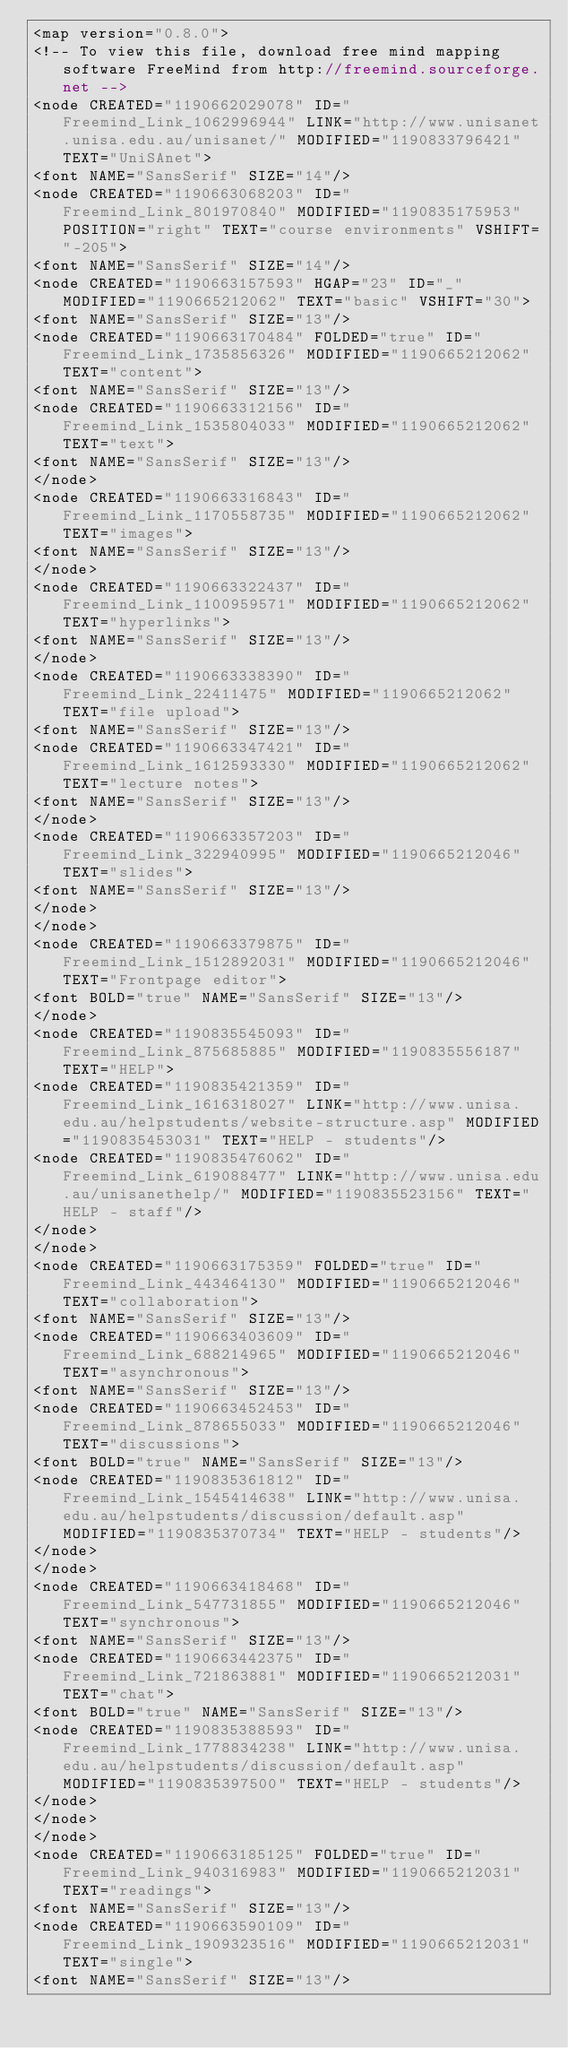<code> <loc_0><loc_0><loc_500><loc_500><_ObjectiveC_><map version="0.8.0">
<!-- To view this file, download free mind mapping software FreeMind from http://freemind.sourceforge.net -->
<node CREATED="1190662029078" ID="Freemind_Link_1062996944" LINK="http://www.unisanet.unisa.edu.au/unisanet/" MODIFIED="1190833796421" TEXT="UniSAnet">
<font NAME="SansSerif" SIZE="14"/>
<node CREATED="1190663068203" ID="Freemind_Link_801970840" MODIFIED="1190835175953" POSITION="right" TEXT="course environments" VSHIFT="-205">
<font NAME="SansSerif" SIZE="14"/>
<node CREATED="1190663157593" HGAP="23" ID="_" MODIFIED="1190665212062" TEXT="basic" VSHIFT="30">
<font NAME="SansSerif" SIZE="13"/>
<node CREATED="1190663170484" FOLDED="true" ID="Freemind_Link_1735856326" MODIFIED="1190665212062" TEXT="content">
<font NAME="SansSerif" SIZE="13"/>
<node CREATED="1190663312156" ID="Freemind_Link_1535804033" MODIFIED="1190665212062" TEXT="text">
<font NAME="SansSerif" SIZE="13"/>
</node>
<node CREATED="1190663316843" ID="Freemind_Link_1170558735" MODIFIED="1190665212062" TEXT="images">
<font NAME="SansSerif" SIZE="13"/>
</node>
<node CREATED="1190663322437" ID="Freemind_Link_1100959571" MODIFIED="1190665212062" TEXT="hyperlinks">
<font NAME="SansSerif" SIZE="13"/>
</node>
<node CREATED="1190663338390" ID="Freemind_Link_22411475" MODIFIED="1190665212062" TEXT="file upload">
<font NAME="SansSerif" SIZE="13"/>
<node CREATED="1190663347421" ID="Freemind_Link_1612593330" MODIFIED="1190665212062" TEXT="lecture notes">
<font NAME="SansSerif" SIZE="13"/>
</node>
<node CREATED="1190663357203" ID="Freemind_Link_322940995" MODIFIED="1190665212046" TEXT="slides">
<font NAME="SansSerif" SIZE="13"/>
</node>
</node>
<node CREATED="1190663379875" ID="Freemind_Link_1512892031" MODIFIED="1190665212046" TEXT="Frontpage editor">
<font BOLD="true" NAME="SansSerif" SIZE="13"/>
</node>
<node CREATED="1190835545093" ID="Freemind_Link_875685885" MODIFIED="1190835556187" TEXT="HELP">
<node CREATED="1190835421359" ID="Freemind_Link_1616318027" LINK="http://www.unisa.edu.au/helpstudents/website-structure.asp" MODIFIED="1190835453031" TEXT="HELP - students"/>
<node CREATED="1190835476062" ID="Freemind_Link_619088477" LINK="http://www.unisa.edu.au/unisanethelp/" MODIFIED="1190835523156" TEXT="HELP - staff"/>
</node>
</node>
<node CREATED="1190663175359" FOLDED="true" ID="Freemind_Link_443464130" MODIFIED="1190665212046" TEXT="collaboration">
<font NAME="SansSerif" SIZE="13"/>
<node CREATED="1190663403609" ID="Freemind_Link_688214965" MODIFIED="1190665212046" TEXT="asynchronous">
<font NAME="SansSerif" SIZE="13"/>
<node CREATED="1190663452453" ID="Freemind_Link_878655033" MODIFIED="1190665212046" TEXT="discussions">
<font BOLD="true" NAME="SansSerif" SIZE="13"/>
<node CREATED="1190835361812" ID="Freemind_Link_1545414638" LINK="http://www.unisa.edu.au/helpstudents/discussion/default.asp" MODIFIED="1190835370734" TEXT="HELP - students"/>
</node>
</node>
<node CREATED="1190663418468" ID="Freemind_Link_547731855" MODIFIED="1190665212046" TEXT="synchronous">
<font NAME="SansSerif" SIZE="13"/>
<node CREATED="1190663442375" ID="Freemind_Link_721863881" MODIFIED="1190665212031" TEXT="chat">
<font BOLD="true" NAME="SansSerif" SIZE="13"/>
<node CREATED="1190835388593" ID="Freemind_Link_1778834238" LINK="http://www.unisa.edu.au/helpstudents/discussion/default.asp" MODIFIED="1190835397500" TEXT="HELP - students"/>
</node>
</node>
</node>
<node CREATED="1190663185125" FOLDED="true" ID="Freemind_Link_940316983" MODIFIED="1190665212031" TEXT="readings">
<font NAME="SansSerif" SIZE="13"/>
<node CREATED="1190663590109" ID="Freemind_Link_1909323516" MODIFIED="1190665212031" TEXT="single">
<font NAME="SansSerif" SIZE="13"/></code> 